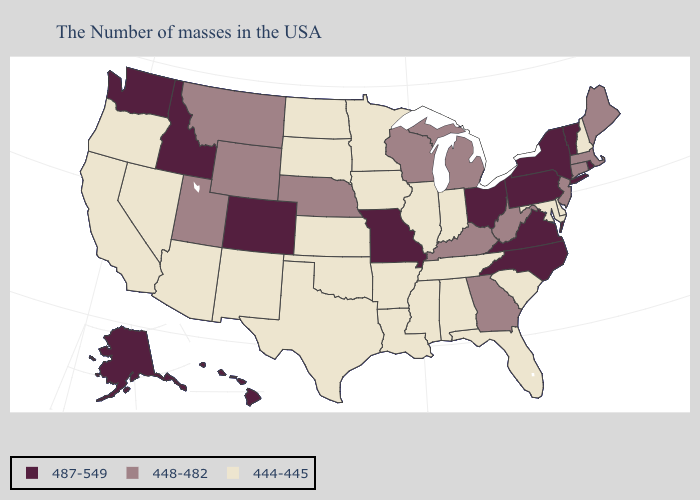What is the value of Virginia?
Keep it brief. 487-549. Among the states that border Washington , which have the highest value?
Quick response, please. Idaho. What is the lowest value in states that border Oklahoma?
Answer briefly. 444-445. What is the highest value in states that border Virginia?
Concise answer only. 487-549. What is the lowest value in the USA?
Keep it brief. 444-445. What is the lowest value in the MidWest?
Write a very short answer. 444-445. What is the lowest value in the MidWest?
Write a very short answer. 444-445. What is the value of Maryland?
Give a very brief answer. 444-445. What is the value of Indiana?
Be succinct. 444-445. Does North Carolina have the highest value in the USA?
Quick response, please. Yes. What is the value of Maine?
Quick response, please. 448-482. Name the states that have a value in the range 448-482?
Concise answer only. Maine, Massachusetts, Connecticut, New Jersey, West Virginia, Georgia, Michigan, Kentucky, Wisconsin, Nebraska, Wyoming, Utah, Montana. Name the states that have a value in the range 487-549?
Concise answer only. Rhode Island, Vermont, New York, Pennsylvania, Virginia, North Carolina, Ohio, Missouri, Colorado, Idaho, Washington, Alaska, Hawaii. Is the legend a continuous bar?
Write a very short answer. No. What is the lowest value in the USA?
Write a very short answer. 444-445. 